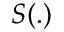<formula> <loc_0><loc_0><loc_500><loc_500>S ( . )</formula> 